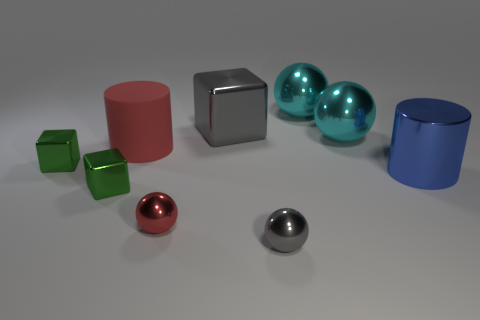Subtract all large gray metal blocks. How many blocks are left? 2 Add 1 tiny objects. How many objects exist? 10 Subtract all gray blocks. How many blocks are left? 2 Subtract all large blue matte balls. Subtract all matte things. How many objects are left? 8 Add 4 tiny metal spheres. How many tiny metal spheres are left? 6 Add 4 big shiny blocks. How many big shiny blocks exist? 5 Subtract 0 green cylinders. How many objects are left? 9 Subtract all balls. How many objects are left? 5 Subtract 1 blocks. How many blocks are left? 2 Subtract all blue cylinders. Subtract all blue balls. How many cylinders are left? 1 